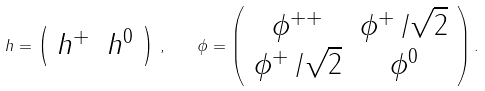<formula> <loc_0><loc_0><loc_500><loc_500>h = \left ( \begin{array} { c c } h ^ { + } & h ^ { 0 } \end{array} \right ) \, , \quad \phi = \left ( \begin{array} { c c } \phi ^ { + + } & \phi ^ { + } \, / \sqrt { 2 } \\ \phi ^ { + } \, / \sqrt { 2 } & \phi ^ { 0 } \end{array} \right ) .</formula> 